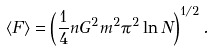<formula> <loc_0><loc_0><loc_500><loc_500>\langle F \rangle = \left ( \frac { 1 } { 4 } n G ^ { 2 } m ^ { 2 } \pi ^ { 2 } \ln N \right ) ^ { 1 / 2 } .</formula> 